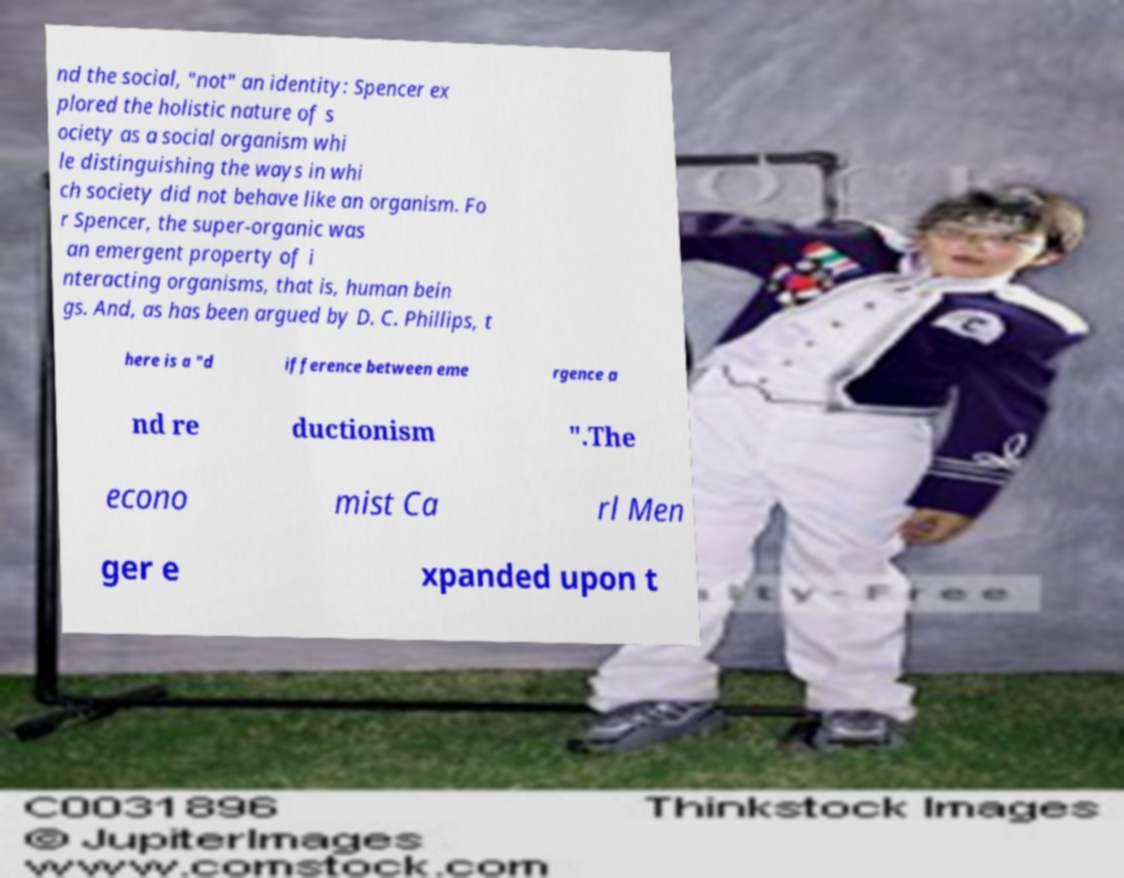There's text embedded in this image that I need extracted. Can you transcribe it verbatim? nd the social, "not" an identity: Spencer ex plored the holistic nature of s ociety as a social organism whi le distinguishing the ways in whi ch society did not behave like an organism. Fo r Spencer, the super-organic was an emergent property of i nteracting organisms, that is, human bein gs. And, as has been argued by D. C. Phillips, t here is a "d ifference between eme rgence a nd re ductionism ".The econo mist Ca rl Men ger e xpanded upon t 